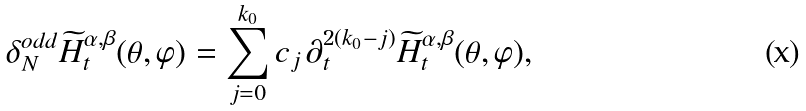<formula> <loc_0><loc_0><loc_500><loc_500>\delta _ { N } ^ { o d d } \widetilde { H } _ { t } ^ { \alpha , \beta } ( \theta , \varphi ) = \sum _ { j = 0 } ^ { k _ { 0 } } c _ { j } \, \partial _ { t } ^ { 2 ( k _ { 0 } - j ) } \widetilde { H } _ { t } ^ { \alpha , \beta } ( \theta , \varphi ) ,</formula> 